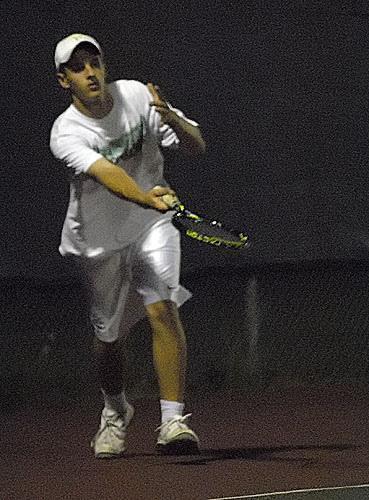How many people are playing in the photo?
Give a very brief answer. 1. 